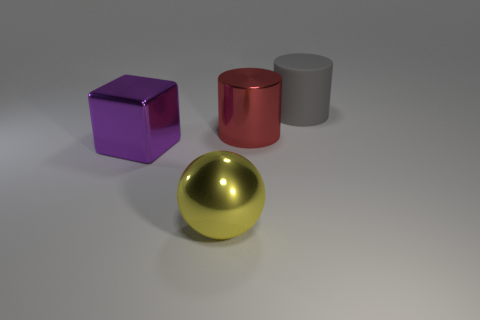There is a cylinder right of the red object; what number of metallic cubes are right of it?
Offer a very short reply. 0. What number of other objects are the same size as the purple shiny thing?
Your response must be concise. 3. Do the large matte cylinder and the large shiny ball have the same color?
Offer a very short reply. No. There is a rubber object behind the block; is its shape the same as the purple thing?
Give a very brief answer. No. How many objects are both right of the large ball and to the left of the metal sphere?
Offer a terse response. 0. What is the purple cube made of?
Your answer should be compact. Metal. Are there any other things that have the same color as the large matte cylinder?
Offer a terse response. No. Are the big red cylinder and the gray thing made of the same material?
Offer a terse response. No. There is a cylinder in front of the large cylinder that is to the right of the large shiny cylinder; how many large objects are in front of it?
Provide a short and direct response. 2. How many green metallic cylinders are there?
Provide a short and direct response. 0. 